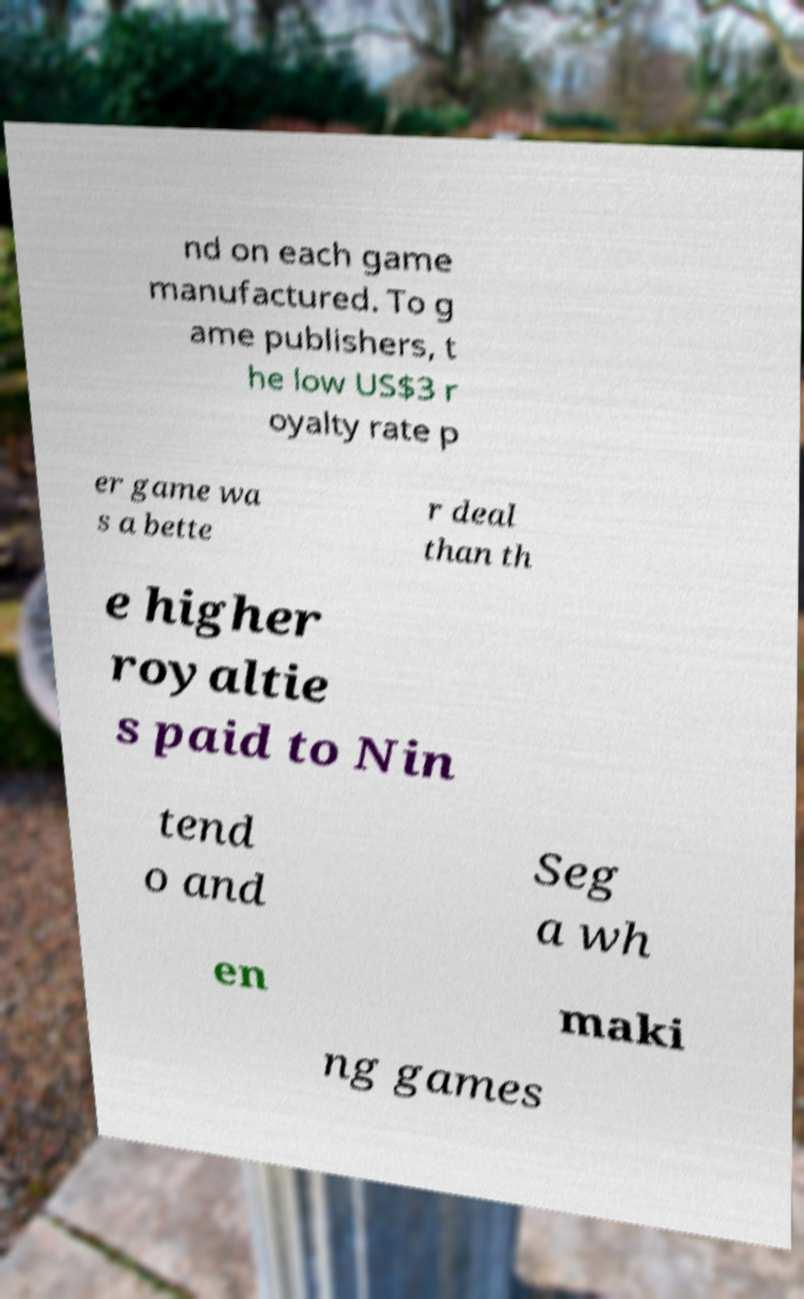Please identify and transcribe the text found in this image. nd on each game manufactured. To g ame publishers, t he low US$3 r oyalty rate p er game wa s a bette r deal than th e higher royaltie s paid to Nin tend o and Seg a wh en maki ng games 